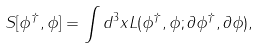Convert formula to latex. <formula><loc_0><loc_0><loc_500><loc_500>S [ \phi ^ { \dagger } , \phi ] = \int d ^ { 3 } x L ( \phi ^ { \dagger } , \phi ; \partial \phi ^ { \dagger } , \partial \phi ) ,</formula> 